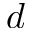Convert formula to latex. <formula><loc_0><loc_0><loc_500><loc_500>d</formula> 